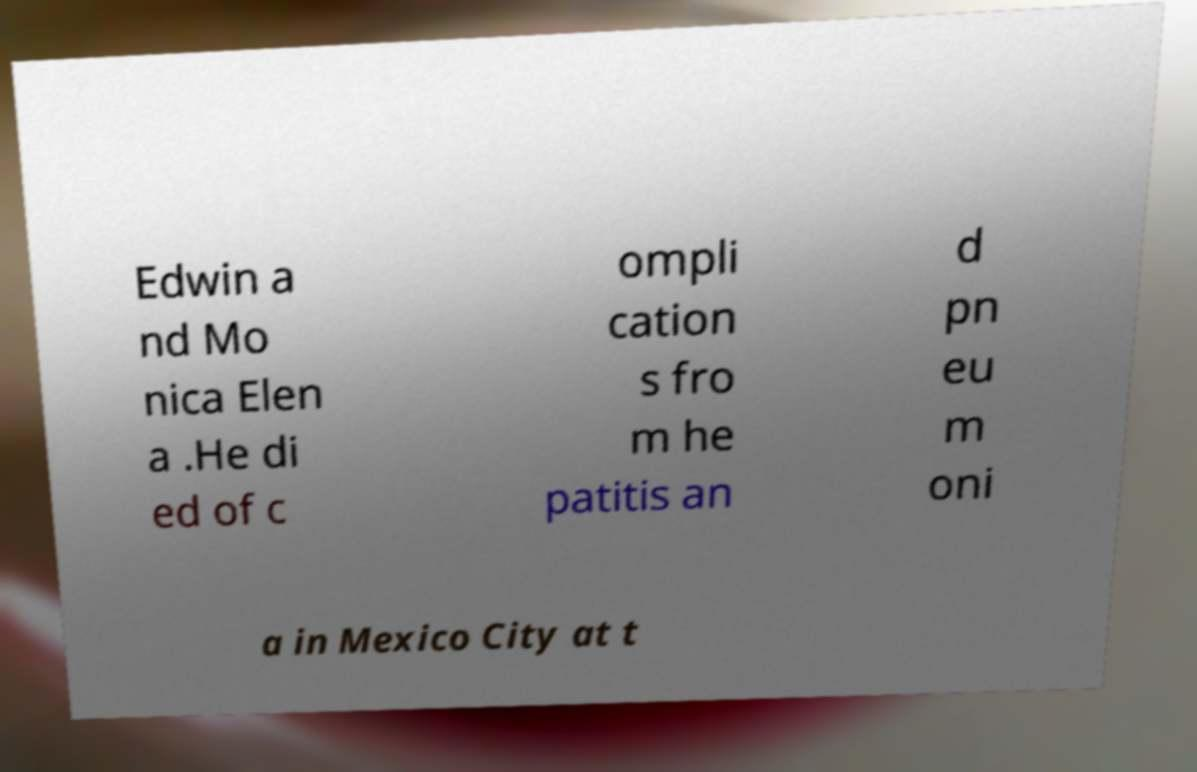What messages or text are displayed in this image? I need them in a readable, typed format. Edwin a nd Mo nica Elen a .He di ed of c ompli cation s fro m he patitis an d pn eu m oni a in Mexico City at t 